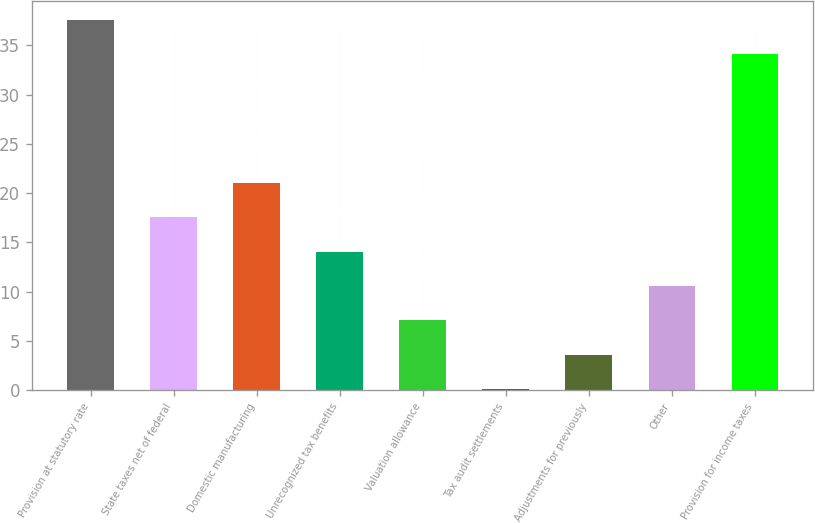<chart> <loc_0><loc_0><loc_500><loc_500><bar_chart><fcel>Provision at statutory rate<fcel>State taxes net of federal<fcel>Domestic manufacturing<fcel>Unrecognized tax benefits<fcel>Valuation allowance<fcel>Tax audit settlements<fcel>Adjustments for previously<fcel>Other<fcel>Provision for income taxes<nl><fcel>37.59<fcel>17.55<fcel>21.04<fcel>14.06<fcel>7.08<fcel>0.1<fcel>3.59<fcel>10.57<fcel>34.1<nl></chart> 